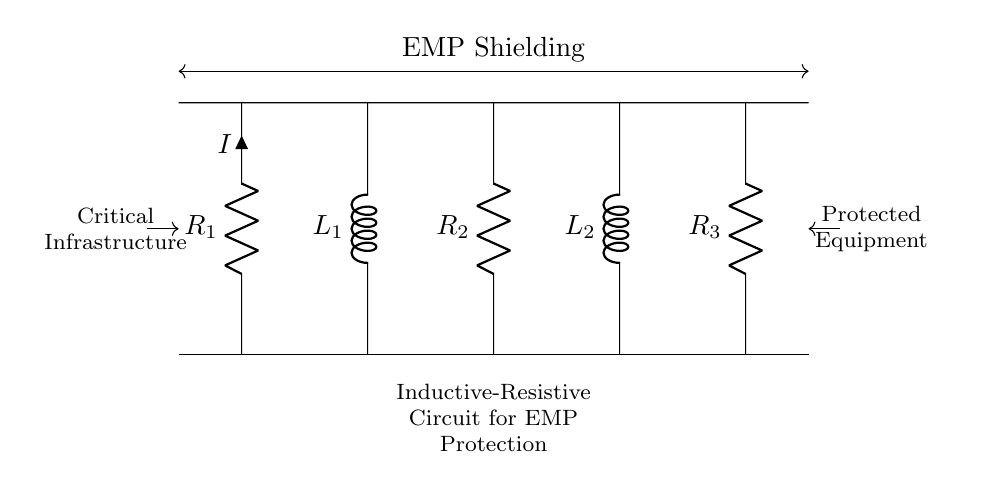What are the types of components in this circuit? The circuit contains resistors and inductors. Specifically, it has three resistors labeled R1, R2, and R3, and two inductors labeled L1 and L2. These components are noted in the circuit diagram.
Answer: resistors and inductors How many resistors are present in the circuit? The circuit diagram indicates a total of three resistors: R1, R2, and R3. Their distinct labels confirm their presence in the circuit.
Answer: three What is the primary function of this circuit? The primary function of the circuit is to provide electromagnetic pulse (EMP) shielding, as indicated by the label above the circuit. EMP shielding is essential for protecting critical infrastructure from electromagnetic interference.
Answer: EMP shielding What is the relationship between the inductors and their placement in the circuit? The inductors are placed in series with resistors. This configuration affects the overall impedance and response to transient signals, making the inductors crucial for filtering out unwanted frequencies caused by EMPs.
Answer: series with resistors What will happen to the current if one resistor fails? If one of the resistors fails (open circuit), the current through that path will drop to zero, affecting the overall functioning of the circuit and potentially compromising EMP protection. The remaining components would still allow some current to pass through but might decrease overall effectiveness.
Answer: current drops to zero How does the inductance in the circuit contribute to its function? The inductance in the circuit acts to oppose changes in current, which is essential during EMP events. It helps filter and stabilize the output by absorbing sudden spikes in current, thereby protecting sensitive equipment from damage.
Answer: absorbs sudden spikes 